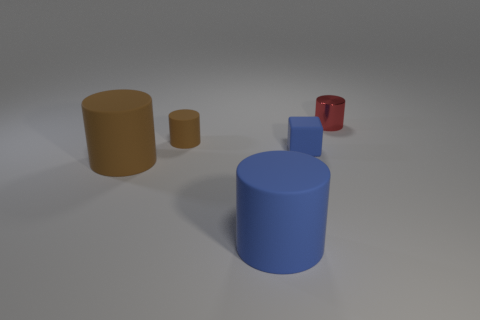Subtract all small red cylinders. How many cylinders are left? 3 Subtract all blue cylinders. How many cylinders are left? 3 Subtract all blocks. How many objects are left? 4 Subtract 1 blocks. How many blocks are left? 0 Subtract all green blocks. How many purple cylinders are left? 0 Subtract all purple cubes. Subtract all tiny metal things. How many objects are left? 4 Add 3 red metallic things. How many red metallic things are left? 4 Add 1 green rubber blocks. How many green rubber blocks exist? 1 Add 4 blue matte cubes. How many objects exist? 9 Subtract 0 yellow cylinders. How many objects are left? 5 